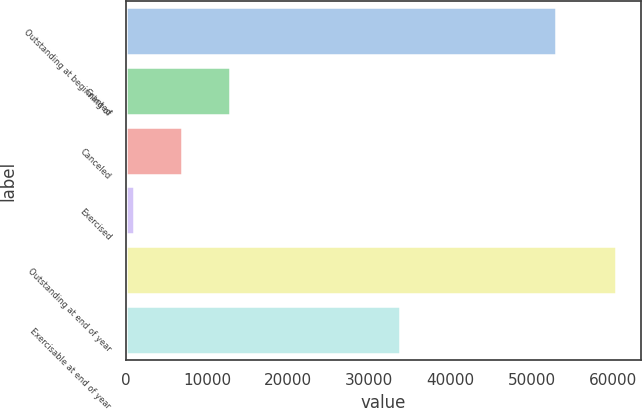Convert chart. <chart><loc_0><loc_0><loc_500><loc_500><bar_chart><fcel>Outstanding at beginning of<fcel>Granted<fcel>Canceled<fcel>Exercised<fcel>Outstanding at end of year<fcel>Exercisable at end of year<nl><fcel>52943<fcel>12842.4<fcel>6896.7<fcel>951<fcel>60408<fcel>33807<nl></chart> 